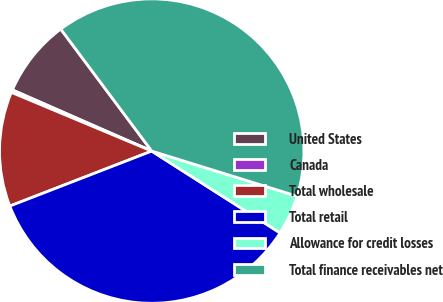Convert chart. <chart><loc_0><loc_0><loc_500><loc_500><pie_chart><fcel>United States<fcel>Canada<fcel>Total wholesale<fcel>Total retail<fcel>Allowance for credit losses<fcel>Total finance receivables net<nl><fcel>8.22%<fcel>0.28%<fcel>12.19%<fcel>35.09%<fcel>4.25%<fcel>39.99%<nl></chart> 